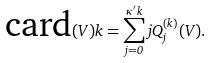<formula> <loc_0><loc_0><loc_500><loc_500>\text {card} ( V ) k = \sum _ { j = 0 } ^ { \kappa ^ { \prime } k } j Q _ { j } ^ { ( k ) } ( V ) .</formula> 